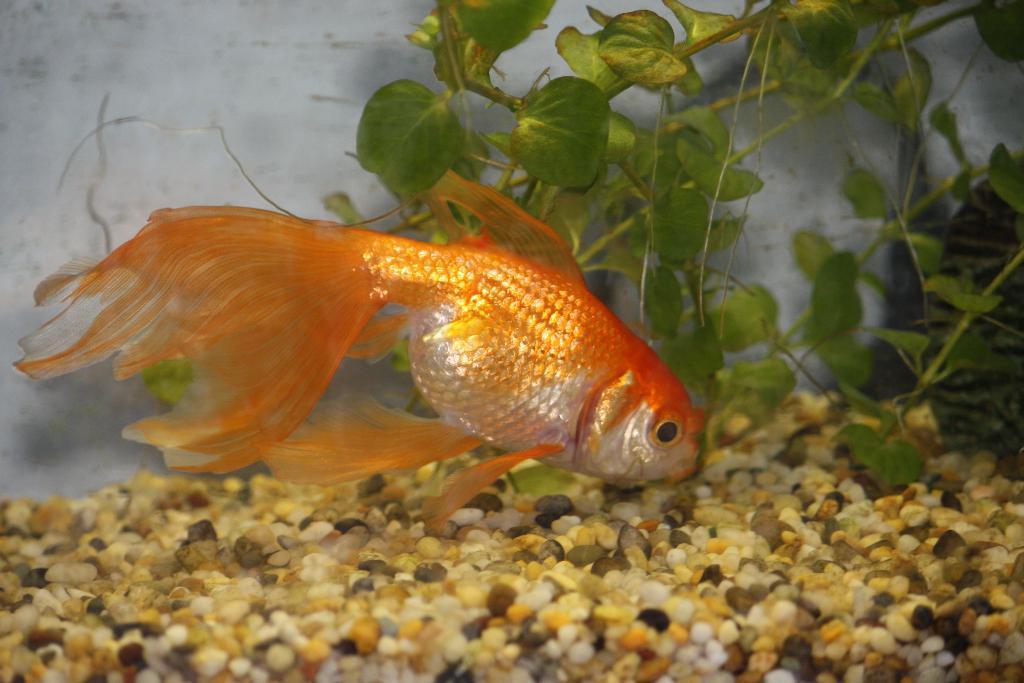Can you describe this image briefly? In this image I can see a gold fish and I can see number of stones and in the background I can see the plants and the white color thing. 